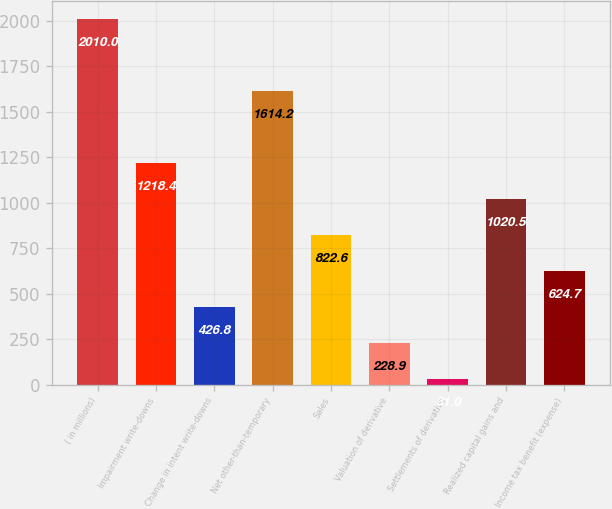Convert chart. <chart><loc_0><loc_0><loc_500><loc_500><bar_chart><fcel>( in millions)<fcel>Impairment write-downs<fcel>Change in intent write-downs<fcel>Net other-than-temporary<fcel>Sales<fcel>Valuation of derivative<fcel>Settlements of derivative<fcel>Realized capital gains and<fcel>Income tax benefit (expense)<nl><fcel>2010<fcel>1218.4<fcel>426.8<fcel>1614.2<fcel>822.6<fcel>228.9<fcel>31<fcel>1020.5<fcel>624.7<nl></chart> 